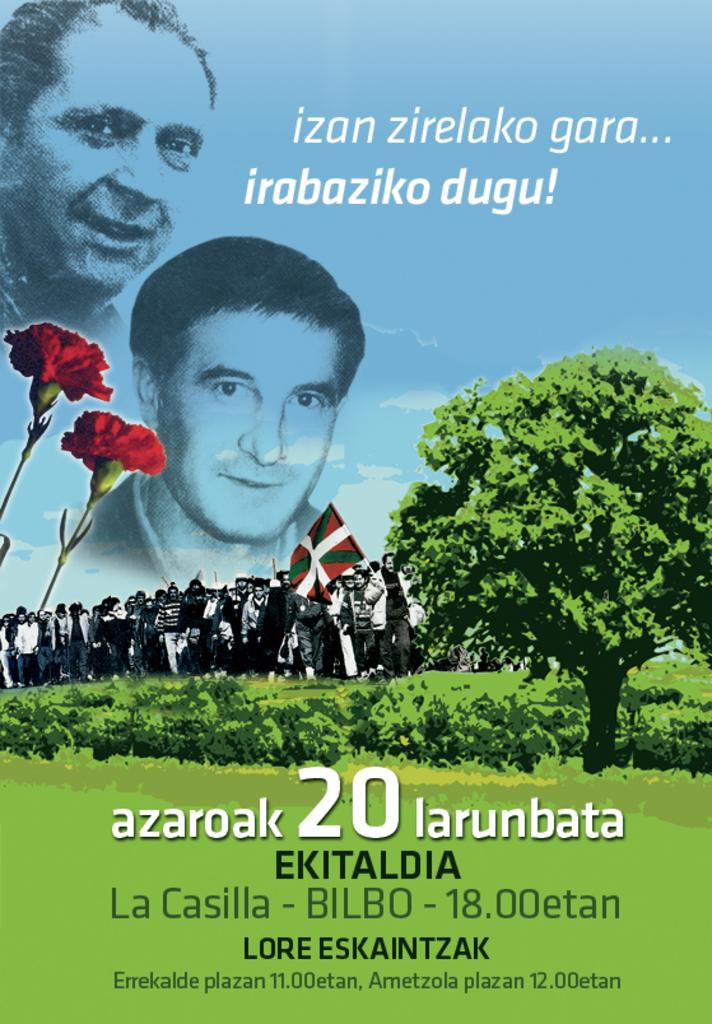<image>
Summarize the visual content of the image. a poster with the number 20 on it 